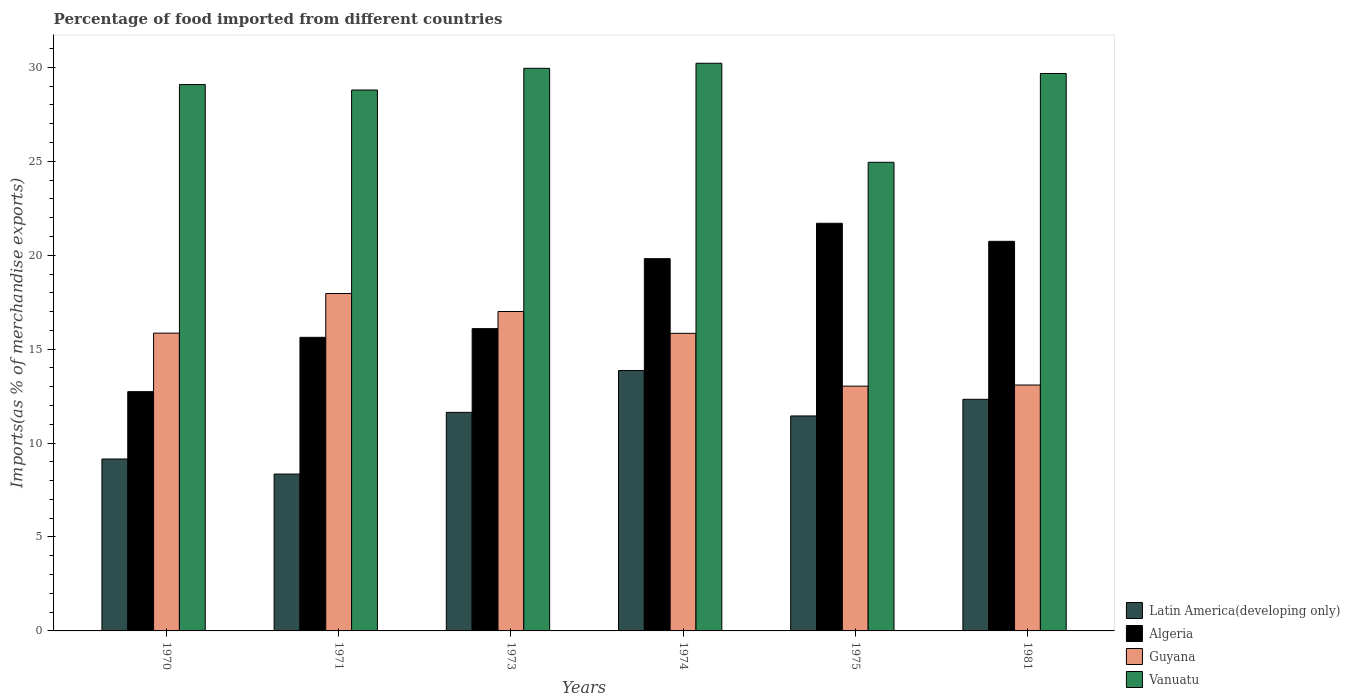Are the number of bars on each tick of the X-axis equal?
Ensure brevity in your answer.  Yes. How many bars are there on the 3rd tick from the right?
Your answer should be very brief. 4. What is the percentage of imports to different countries in Guyana in 1970?
Ensure brevity in your answer.  15.85. Across all years, what is the maximum percentage of imports to different countries in Algeria?
Ensure brevity in your answer.  21.7. Across all years, what is the minimum percentage of imports to different countries in Latin America(developing only)?
Make the answer very short. 8.35. What is the total percentage of imports to different countries in Algeria in the graph?
Your response must be concise. 106.72. What is the difference between the percentage of imports to different countries in Algeria in 1971 and that in 1974?
Offer a very short reply. -4.19. What is the difference between the percentage of imports to different countries in Latin America(developing only) in 1981 and the percentage of imports to different countries in Vanuatu in 1970?
Your response must be concise. -16.76. What is the average percentage of imports to different countries in Vanuatu per year?
Ensure brevity in your answer.  28.78. In the year 1973, what is the difference between the percentage of imports to different countries in Algeria and percentage of imports to different countries in Vanuatu?
Your answer should be very brief. -13.86. In how many years, is the percentage of imports to different countries in Vanuatu greater than 14 %?
Give a very brief answer. 6. What is the ratio of the percentage of imports to different countries in Latin America(developing only) in 1973 to that in 1981?
Offer a very short reply. 0.94. Is the percentage of imports to different countries in Algeria in 1973 less than that in 1975?
Give a very brief answer. Yes. What is the difference between the highest and the second highest percentage of imports to different countries in Latin America(developing only)?
Ensure brevity in your answer.  1.53. What is the difference between the highest and the lowest percentage of imports to different countries in Vanuatu?
Offer a very short reply. 5.27. In how many years, is the percentage of imports to different countries in Latin America(developing only) greater than the average percentage of imports to different countries in Latin America(developing only) taken over all years?
Your answer should be compact. 4. Is the sum of the percentage of imports to different countries in Guyana in 1973 and 1974 greater than the maximum percentage of imports to different countries in Vanuatu across all years?
Make the answer very short. Yes. Is it the case that in every year, the sum of the percentage of imports to different countries in Latin America(developing only) and percentage of imports to different countries in Algeria is greater than the sum of percentage of imports to different countries in Vanuatu and percentage of imports to different countries in Guyana?
Keep it short and to the point. No. What does the 3rd bar from the left in 1981 represents?
Your answer should be compact. Guyana. What does the 2nd bar from the right in 1971 represents?
Offer a terse response. Guyana. Is it the case that in every year, the sum of the percentage of imports to different countries in Vanuatu and percentage of imports to different countries in Algeria is greater than the percentage of imports to different countries in Latin America(developing only)?
Provide a succinct answer. Yes. Are all the bars in the graph horizontal?
Provide a succinct answer. No. How many years are there in the graph?
Ensure brevity in your answer.  6. Are the values on the major ticks of Y-axis written in scientific E-notation?
Offer a terse response. No. Does the graph contain any zero values?
Make the answer very short. No. Where does the legend appear in the graph?
Your answer should be compact. Bottom right. How many legend labels are there?
Keep it short and to the point. 4. What is the title of the graph?
Your answer should be very brief. Percentage of food imported from different countries. Does "Low & middle income" appear as one of the legend labels in the graph?
Offer a very short reply. No. What is the label or title of the Y-axis?
Provide a short and direct response. Imports(as % of merchandise exports). What is the Imports(as % of merchandise exports) of Latin America(developing only) in 1970?
Give a very brief answer. 9.15. What is the Imports(as % of merchandise exports) in Algeria in 1970?
Keep it short and to the point. 12.74. What is the Imports(as % of merchandise exports) of Guyana in 1970?
Provide a succinct answer. 15.85. What is the Imports(as % of merchandise exports) of Vanuatu in 1970?
Provide a succinct answer. 29.09. What is the Imports(as % of merchandise exports) in Latin America(developing only) in 1971?
Provide a succinct answer. 8.35. What is the Imports(as % of merchandise exports) in Algeria in 1971?
Ensure brevity in your answer.  15.63. What is the Imports(as % of merchandise exports) of Guyana in 1971?
Keep it short and to the point. 17.96. What is the Imports(as % of merchandise exports) in Vanuatu in 1971?
Make the answer very short. 28.8. What is the Imports(as % of merchandise exports) of Latin America(developing only) in 1973?
Offer a terse response. 11.64. What is the Imports(as % of merchandise exports) of Algeria in 1973?
Offer a very short reply. 16.09. What is the Imports(as % of merchandise exports) in Guyana in 1973?
Provide a succinct answer. 17. What is the Imports(as % of merchandise exports) of Vanuatu in 1973?
Your response must be concise. 29.95. What is the Imports(as % of merchandise exports) in Latin America(developing only) in 1974?
Ensure brevity in your answer.  13.86. What is the Imports(as % of merchandise exports) of Algeria in 1974?
Your answer should be compact. 19.82. What is the Imports(as % of merchandise exports) in Guyana in 1974?
Provide a succinct answer. 15.84. What is the Imports(as % of merchandise exports) in Vanuatu in 1974?
Keep it short and to the point. 30.22. What is the Imports(as % of merchandise exports) of Latin America(developing only) in 1975?
Give a very brief answer. 11.44. What is the Imports(as % of merchandise exports) in Algeria in 1975?
Offer a very short reply. 21.7. What is the Imports(as % of merchandise exports) of Guyana in 1975?
Provide a succinct answer. 13.03. What is the Imports(as % of merchandise exports) in Vanuatu in 1975?
Your response must be concise. 24.95. What is the Imports(as % of merchandise exports) in Latin America(developing only) in 1981?
Keep it short and to the point. 12.33. What is the Imports(as % of merchandise exports) in Algeria in 1981?
Your answer should be very brief. 20.74. What is the Imports(as % of merchandise exports) of Guyana in 1981?
Keep it short and to the point. 13.09. What is the Imports(as % of merchandise exports) of Vanuatu in 1981?
Offer a terse response. 29.67. Across all years, what is the maximum Imports(as % of merchandise exports) of Latin America(developing only)?
Offer a terse response. 13.86. Across all years, what is the maximum Imports(as % of merchandise exports) of Algeria?
Give a very brief answer. 21.7. Across all years, what is the maximum Imports(as % of merchandise exports) of Guyana?
Offer a very short reply. 17.96. Across all years, what is the maximum Imports(as % of merchandise exports) of Vanuatu?
Your response must be concise. 30.22. Across all years, what is the minimum Imports(as % of merchandise exports) in Latin America(developing only)?
Provide a succinct answer. 8.35. Across all years, what is the minimum Imports(as % of merchandise exports) of Algeria?
Provide a succinct answer. 12.74. Across all years, what is the minimum Imports(as % of merchandise exports) in Guyana?
Offer a terse response. 13.03. Across all years, what is the minimum Imports(as % of merchandise exports) in Vanuatu?
Provide a short and direct response. 24.95. What is the total Imports(as % of merchandise exports) of Latin America(developing only) in the graph?
Offer a very short reply. 66.77. What is the total Imports(as % of merchandise exports) of Algeria in the graph?
Make the answer very short. 106.72. What is the total Imports(as % of merchandise exports) of Guyana in the graph?
Your response must be concise. 92.78. What is the total Imports(as % of merchandise exports) in Vanuatu in the graph?
Provide a short and direct response. 172.68. What is the difference between the Imports(as % of merchandise exports) of Latin America(developing only) in 1970 and that in 1971?
Give a very brief answer. 0.8. What is the difference between the Imports(as % of merchandise exports) in Algeria in 1970 and that in 1971?
Provide a succinct answer. -2.89. What is the difference between the Imports(as % of merchandise exports) of Guyana in 1970 and that in 1971?
Give a very brief answer. -2.11. What is the difference between the Imports(as % of merchandise exports) in Vanuatu in 1970 and that in 1971?
Provide a short and direct response. 0.29. What is the difference between the Imports(as % of merchandise exports) in Latin America(developing only) in 1970 and that in 1973?
Your answer should be very brief. -2.48. What is the difference between the Imports(as % of merchandise exports) of Algeria in 1970 and that in 1973?
Offer a terse response. -3.36. What is the difference between the Imports(as % of merchandise exports) of Guyana in 1970 and that in 1973?
Provide a succinct answer. -1.15. What is the difference between the Imports(as % of merchandise exports) in Vanuatu in 1970 and that in 1973?
Offer a terse response. -0.86. What is the difference between the Imports(as % of merchandise exports) in Latin America(developing only) in 1970 and that in 1974?
Offer a very short reply. -4.71. What is the difference between the Imports(as % of merchandise exports) of Algeria in 1970 and that in 1974?
Your answer should be very brief. -7.08. What is the difference between the Imports(as % of merchandise exports) in Guyana in 1970 and that in 1974?
Make the answer very short. 0.01. What is the difference between the Imports(as % of merchandise exports) of Vanuatu in 1970 and that in 1974?
Provide a short and direct response. -1.13. What is the difference between the Imports(as % of merchandise exports) of Latin America(developing only) in 1970 and that in 1975?
Your answer should be compact. -2.29. What is the difference between the Imports(as % of merchandise exports) in Algeria in 1970 and that in 1975?
Keep it short and to the point. -8.96. What is the difference between the Imports(as % of merchandise exports) of Guyana in 1970 and that in 1975?
Your response must be concise. 2.82. What is the difference between the Imports(as % of merchandise exports) of Vanuatu in 1970 and that in 1975?
Your response must be concise. 4.14. What is the difference between the Imports(as % of merchandise exports) of Latin America(developing only) in 1970 and that in 1981?
Provide a succinct answer. -3.18. What is the difference between the Imports(as % of merchandise exports) of Algeria in 1970 and that in 1981?
Ensure brevity in your answer.  -8. What is the difference between the Imports(as % of merchandise exports) in Guyana in 1970 and that in 1981?
Your answer should be very brief. 2.76. What is the difference between the Imports(as % of merchandise exports) in Vanuatu in 1970 and that in 1981?
Offer a very short reply. -0.59. What is the difference between the Imports(as % of merchandise exports) in Latin America(developing only) in 1971 and that in 1973?
Offer a terse response. -3.28. What is the difference between the Imports(as % of merchandise exports) in Algeria in 1971 and that in 1973?
Offer a very short reply. -0.46. What is the difference between the Imports(as % of merchandise exports) of Guyana in 1971 and that in 1973?
Give a very brief answer. 0.96. What is the difference between the Imports(as % of merchandise exports) of Vanuatu in 1971 and that in 1973?
Give a very brief answer. -1.15. What is the difference between the Imports(as % of merchandise exports) of Latin America(developing only) in 1971 and that in 1974?
Offer a terse response. -5.51. What is the difference between the Imports(as % of merchandise exports) of Algeria in 1971 and that in 1974?
Make the answer very short. -4.19. What is the difference between the Imports(as % of merchandise exports) of Guyana in 1971 and that in 1974?
Offer a very short reply. 2.12. What is the difference between the Imports(as % of merchandise exports) of Vanuatu in 1971 and that in 1974?
Offer a very short reply. -1.42. What is the difference between the Imports(as % of merchandise exports) of Latin America(developing only) in 1971 and that in 1975?
Ensure brevity in your answer.  -3.09. What is the difference between the Imports(as % of merchandise exports) of Algeria in 1971 and that in 1975?
Provide a succinct answer. -6.07. What is the difference between the Imports(as % of merchandise exports) of Guyana in 1971 and that in 1975?
Your response must be concise. 4.93. What is the difference between the Imports(as % of merchandise exports) of Vanuatu in 1971 and that in 1975?
Your answer should be compact. 3.85. What is the difference between the Imports(as % of merchandise exports) in Latin America(developing only) in 1971 and that in 1981?
Keep it short and to the point. -3.98. What is the difference between the Imports(as % of merchandise exports) of Algeria in 1971 and that in 1981?
Offer a terse response. -5.11. What is the difference between the Imports(as % of merchandise exports) of Guyana in 1971 and that in 1981?
Make the answer very short. 4.87. What is the difference between the Imports(as % of merchandise exports) of Vanuatu in 1971 and that in 1981?
Your answer should be compact. -0.88. What is the difference between the Imports(as % of merchandise exports) in Latin America(developing only) in 1973 and that in 1974?
Provide a short and direct response. -2.23. What is the difference between the Imports(as % of merchandise exports) in Algeria in 1973 and that in 1974?
Offer a terse response. -3.72. What is the difference between the Imports(as % of merchandise exports) of Guyana in 1973 and that in 1974?
Provide a succinct answer. 1.16. What is the difference between the Imports(as % of merchandise exports) in Vanuatu in 1973 and that in 1974?
Give a very brief answer. -0.27. What is the difference between the Imports(as % of merchandise exports) in Latin America(developing only) in 1973 and that in 1975?
Your answer should be compact. 0.19. What is the difference between the Imports(as % of merchandise exports) of Algeria in 1973 and that in 1975?
Your answer should be very brief. -5.61. What is the difference between the Imports(as % of merchandise exports) of Guyana in 1973 and that in 1975?
Your response must be concise. 3.97. What is the difference between the Imports(as % of merchandise exports) in Vanuatu in 1973 and that in 1975?
Your answer should be very brief. 5. What is the difference between the Imports(as % of merchandise exports) of Latin America(developing only) in 1973 and that in 1981?
Provide a short and direct response. -0.7. What is the difference between the Imports(as % of merchandise exports) in Algeria in 1973 and that in 1981?
Ensure brevity in your answer.  -4.65. What is the difference between the Imports(as % of merchandise exports) in Guyana in 1973 and that in 1981?
Offer a very short reply. 3.91. What is the difference between the Imports(as % of merchandise exports) in Vanuatu in 1973 and that in 1981?
Make the answer very short. 0.28. What is the difference between the Imports(as % of merchandise exports) of Latin America(developing only) in 1974 and that in 1975?
Your answer should be very brief. 2.42. What is the difference between the Imports(as % of merchandise exports) of Algeria in 1974 and that in 1975?
Ensure brevity in your answer.  -1.88. What is the difference between the Imports(as % of merchandise exports) of Guyana in 1974 and that in 1975?
Ensure brevity in your answer.  2.81. What is the difference between the Imports(as % of merchandise exports) in Vanuatu in 1974 and that in 1975?
Give a very brief answer. 5.27. What is the difference between the Imports(as % of merchandise exports) of Latin America(developing only) in 1974 and that in 1981?
Give a very brief answer. 1.53. What is the difference between the Imports(as % of merchandise exports) of Algeria in 1974 and that in 1981?
Keep it short and to the point. -0.92. What is the difference between the Imports(as % of merchandise exports) in Guyana in 1974 and that in 1981?
Your answer should be very brief. 2.75. What is the difference between the Imports(as % of merchandise exports) of Vanuatu in 1974 and that in 1981?
Your answer should be compact. 0.55. What is the difference between the Imports(as % of merchandise exports) of Latin America(developing only) in 1975 and that in 1981?
Offer a very short reply. -0.89. What is the difference between the Imports(as % of merchandise exports) in Algeria in 1975 and that in 1981?
Give a very brief answer. 0.96. What is the difference between the Imports(as % of merchandise exports) in Guyana in 1975 and that in 1981?
Provide a succinct answer. -0.06. What is the difference between the Imports(as % of merchandise exports) of Vanuatu in 1975 and that in 1981?
Keep it short and to the point. -4.73. What is the difference between the Imports(as % of merchandise exports) in Latin America(developing only) in 1970 and the Imports(as % of merchandise exports) in Algeria in 1971?
Offer a terse response. -6.48. What is the difference between the Imports(as % of merchandise exports) of Latin America(developing only) in 1970 and the Imports(as % of merchandise exports) of Guyana in 1971?
Offer a terse response. -8.81. What is the difference between the Imports(as % of merchandise exports) in Latin America(developing only) in 1970 and the Imports(as % of merchandise exports) in Vanuatu in 1971?
Offer a terse response. -19.64. What is the difference between the Imports(as % of merchandise exports) of Algeria in 1970 and the Imports(as % of merchandise exports) of Guyana in 1971?
Offer a very short reply. -5.22. What is the difference between the Imports(as % of merchandise exports) of Algeria in 1970 and the Imports(as % of merchandise exports) of Vanuatu in 1971?
Your response must be concise. -16.06. What is the difference between the Imports(as % of merchandise exports) of Guyana in 1970 and the Imports(as % of merchandise exports) of Vanuatu in 1971?
Provide a short and direct response. -12.94. What is the difference between the Imports(as % of merchandise exports) in Latin America(developing only) in 1970 and the Imports(as % of merchandise exports) in Algeria in 1973?
Your answer should be compact. -6.94. What is the difference between the Imports(as % of merchandise exports) in Latin America(developing only) in 1970 and the Imports(as % of merchandise exports) in Guyana in 1973?
Provide a succinct answer. -7.85. What is the difference between the Imports(as % of merchandise exports) in Latin America(developing only) in 1970 and the Imports(as % of merchandise exports) in Vanuatu in 1973?
Offer a terse response. -20.8. What is the difference between the Imports(as % of merchandise exports) of Algeria in 1970 and the Imports(as % of merchandise exports) of Guyana in 1973?
Offer a terse response. -4.27. What is the difference between the Imports(as % of merchandise exports) in Algeria in 1970 and the Imports(as % of merchandise exports) in Vanuatu in 1973?
Give a very brief answer. -17.21. What is the difference between the Imports(as % of merchandise exports) in Guyana in 1970 and the Imports(as % of merchandise exports) in Vanuatu in 1973?
Give a very brief answer. -14.1. What is the difference between the Imports(as % of merchandise exports) of Latin America(developing only) in 1970 and the Imports(as % of merchandise exports) of Algeria in 1974?
Provide a succinct answer. -10.66. What is the difference between the Imports(as % of merchandise exports) of Latin America(developing only) in 1970 and the Imports(as % of merchandise exports) of Guyana in 1974?
Offer a very short reply. -6.69. What is the difference between the Imports(as % of merchandise exports) in Latin America(developing only) in 1970 and the Imports(as % of merchandise exports) in Vanuatu in 1974?
Keep it short and to the point. -21.07. What is the difference between the Imports(as % of merchandise exports) of Algeria in 1970 and the Imports(as % of merchandise exports) of Guyana in 1974?
Your answer should be compact. -3.11. What is the difference between the Imports(as % of merchandise exports) of Algeria in 1970 and the Imports(as % of merchandise exports) of Vanuatu in 1974?
Make the answer very short. -17.48. What is the difference between the Imports(as % of merchandise exports) in Guyana in 1970 and the Imports(as % of merchandise exports) in Vanuatu in 1974?
Offer a terse response. -14.37. What is the difference between the Imports(as % of merchandise exports) of Latin America(developing only) in 1970 and the Imports(as % of merchandise exports) of Algeria in 1975?
Make the answer very short. -12.55. What is the difference between the Imports(as % of merchandise exports) in Latin America(developing only) in 1970 and the Imports(as % of merchandise exports) in Guyana in 1975?
Provide a short and direct response. -3.88. What is the difference between the Imports(as % of merchandise exports) in Latin America(developing only) in 1970 and the Imports(as % of merchandise exports) in Vanuatu in 1975?
Keep it short and to the point. -15.8. What is the difference between the Imports(as % of merchandise exports) in Algeria in 1970 and the Imports(as % of merchandise exports) in Guyana in 1975?
Make the answer very short. -0.29. What is the difference between the Imports(as % of merchandise exports) of Algeria in 1970 and the Imports(as % of merchandise exports) of Vanuatu in 1975?
Make the answer very short. -12.21. What is the difference between the Imports(as % of merchandise exports) in Guyana in 1970 and the Imports(as % of merchandise exports) in Vanuatu in 1975?
Provide a succinct answer. -9.09. What is the difference between the Imports(as % of merchandise exports) in Latin America(developing only) in 1970 and the Imports(as % of merchandise exports) in Algeria in 1981?
Provide a succinct answer. -11.59. What is the difference between the Imports(as % of merchandise exports) in Latin America(developing only) in 1970 and the Imports(as % of merchandise exports) in Guyana in 1981?
Provide a short and direct response. -3.94. What is the difference between the Imports(as % of merchandise exports) of Latin America(developing only) in 1970 and the Imports(as % of merchandise exports) of Vanuatu in 1981?
Provide a succinct answer. -20.52. What is the difference between the Imports(as % of merchandise exports) in Algeria in 1970 and the Imports(as % of merchandise exports) in Guyana in 1981?
Keep it short and to the point. -0.35. What is the difference between the Imports(as % of merchandise exports) in Algeria in 1970 and the Imports(as % of merchandise exports) in Vanuatu in 1981?
Keep it short and to the point. -16.94. What is the difference between the Imports(as % of merchandise exports) of Guyana in 1970 and the Imports(as % of merchandise exports) of Vanuatu in 1981?
Keep it short and to the point. -13.82. What is the difference between the Imports(as % of merchandise exports) of Latin America(developing only) in 1971 and the Imports(as % of merchandise exports) of Algeria in 1973?
Offer a very short reply. -7.74. What is the difference between the Imports(as % of merchandise exports) of Latin America(developing only) in 1971 and the Imports(as % of merchandise exports) of Guyana in 1973?
Make the answer very short. -8.65. What is the difference between the Imports(as % of merchandise exports) of Latin America(developing only) in 1971 and the Imports(as % of merchandise exports) of Vanuatu in 1973?
Make the answer very short. -21.6. What is the difference between the Imports(as % of merchandise exports) in Algeria in 1971 and the Imports(as % of merchandise exports) in Guyana in 1973?
Provide a succinct answer. -1.37. What is the difference between the Imports(as % of merchandise exports) in Algeria in 1971 and the Imports(as % of merchandise exports) in Vanuatu in 1973?
Offer a terse response. -14.32. What is the difference between the Imports(as % of merchandise exports) in Guyana in 1971 and the Imports(as % of merchandise exports) in Vanuatu in 1973?
Offer a very short reply. -11.99. What is the difference between the Imports(as % of merchandise exports) in Latin America(developing only) in 1971 and the Imports(as % of merchandise exports) in Algeria in 1974?
Offer a terse response. -11.47. What is the difference between the Imports(as % of merchandise exports) in Latin America(developing only) in 1971 and the Imports(as % of merchandise exports) in Guyana in 1974?
Your answer should be compact. -7.49. What is the difference between the Imports(as % of merchandise exports) in Latin America(developing only) in 1971 and the Imports(as % of merchandise exports) in Vanuatu in 1974?
Offer a very short reply. -21.87. What is the difference between the Imports(as % of merchandise exports) in Algeria in 1971 and the Imports(as % of merchandise exports) in Guyana in 1974?
Make the answer very short. -0.21. What is the difference between the Imports(as % of merchandise exports) of Algeria in 1971 and the Imports(as % of merchandise exports) of Vanuatu in 1974?
Your response must be concise. -14.59. What is the difference between the Imports(as % of merchandise exports) in Guyana in 1971 and the Imports(as % of merchandise exports) in Vanuatu in 1974?
Keep it short and to the point. -12.26. What is the difference between the Imports(as % of merchandise exports) of Latin America(developing only) in 1971 and the Imports(as % of merchandise exports) of Algeria in 1975?
Your answer should be compact. -13.35. What is the difference between the Imports(as % of merchandise exports) of Latin America(developing only) in 1971 and the Imports(as % of merchandise exports) of Guyana in 1975?
Offer a very short reply. -4.68. What is the difference between the Imports(as % of merchandise exports) in Latin America(developing only) in 1971 and the Imports(as % of merchandise exports) in Vanuatu in 1975?
Keep it short and to the point. -16.6. What is the difference between the Imports(as % of merchandise exports) in Algeria in 1971 and the Imports(as % of merchandise exports) in Guyana in 1975?
Your response must be concise. 2.6. What is the difference between the Imports(as % of merchandise exports) in Algeria in 1971 and the Imports(as % of merchandise exports) in Vanuatu in 1975?
Keep it short and to the point. -9.32. What is the difference between the Imports(as % of merchandise exports) in Guyana in 1971 and the Imports(as % of merchandise exports) in Vanuatu in 1975?
Your answer should be very brief. -6.99. What is the difference between the Imports(as % of merchandise exports) of Latin America(developing only) in 1971 and the Imports(as % of merchandise exports) of Algeria in 1981?
Provide a succinct answer. -12.39. What is the difference between the Imports(as % of merchandise exports) in Latin America(developing only) in 1971 and the Imports(as % of merchandise exports) in Guyana in 1981?
Keep it short and to the point. -4.74. What is the difference between the Imports(as % of merchandise exports) of Latin America(developing only) in 1971 and the Imports(as % of merchandise exports) of Vanuatu in 1981?
Offer a terse response. -21.32. What is the difference between the Imports(as % of merchandise exports) in Algeria in 1971 and the Imports(as % of merchandise exports) in Guyana in 1981?
Provide a succinct answer. 2.54. What is the difference between the Imports(as % of merchandise exports) in Algeria in 1971 and the Imports(as % of merchandise exports) in Vanuatu in 1981?
Make the answer very short. -14.04. What is the difference between the Imports(as % of merchandise exports) of Guyana in 1971 and the Imports(as % of merchandise exports) of Vanuatu in 1981?
Make the answer very short. -11.71. What is the difference between the Imports(as % of merchandise exports) of Latin America(developing only) in 1973 and the Imports(as % of merchandise exports) of Algeria in 1974?
Your answer should be compact. -8.18. What is the difference between the Imports(as % of merchandise exports) of Latin America(developing only) in 1973 and the Imports(as % of merchandise exports) of Guyana in 1974?
Your answer should be compact. -4.21. What is the difference between the Imports(as % of merchandise exports) of Latin America(developing only) in 1973 and the Imports(as % of merchandise exports) of Vanuatu in 1974?
Keep it short and to the point. -18.58. What is the difference between the Imports(as % of merchandise exports) of Algeria in 1973 and the Imports(as % of merchandise exports) of Guyana in 1974?
Provide a short and direct response. 0.25. What is the difference between the Imports(as % of merchandise exports) in Algeria in 1973 and the Imports(as % of merchandise exports) in Vanuatu in 1974?
Your response must be concise. -14.13. What is the difference between the Imports(as % of merchandise exports) in Guyana in 1973 and the Imports(as % of merchandise exports) in Vanuatu in 1974?
Make the answer very short. -13.22. What is the difference between the Imports(as % of merchandise exports) in Latin America(developing only) in 1973 and the Imports(as % of merchandise exports) in Algeria in 1975?
Keep it short and to the point. -10.07. What is the difference between the Imports(as % of merchandise exports) in Latin America(developing only) in 1973 and the Imports(as % of merchandise exports) in Guyana in 1975?
Make the answer very short. -1.4. What is the difference between the Imports(as % of merchandise exports) in Latin America(developing only) in 1973 and the Imports(as % of merchandise exports) in Vanuatu in 1975?
Offer a very short reply. -13.31. What is the difference between the Imports(as % of merchandise exports) in Algeria in 1973 and the Imports(as % of merchandise exports) in Guyana in 1975?
Your answer should be compact. 3.06. What is the difference between the Imports(as % of merchandise exports) in Algeria in 1973 and the Imports(as % of merchandise exports) in Vanuatu in 1975?
Make the answer very short. -8.85. What is the difference between the Imports(as % of merchandise exports) in Guyana in 1973 and the Imports(as % of merchandise exports) in Vanuatu in 1975?
Keep it short and to the point. -7.94. What is the difference between the Imports(as % of merchandise exports) in Latin America(developing only) in 1973 and the Imports(as % of merchandise exports) in Algeria in 1981?
Your response must be concise. -9.11. What is the difference between the Imports(as % of merchandise exports) of Latin America(developing only) in 1973 and the Imports(as % of merchandise exports) of Guyana in 1981?
Offer a very short reply. -1.46. What is the difference between the Imports(as % of merchandise exports) of Latin America(developing only) in 1973 and the Imports(as % of merchandise exports) of Vanuatu in 1981?
Your answer should be compact. -18.04. What is the difference between the Imports(as % of merchandise exports) of Algeria in 1973 and the Imports(as % of merchandise exports) of Guyana in 1981?
Give a very brief answer. 3. What is the difference between the Imports(as % of merchandise exports) of Algeria in 1973 and the Imports(as % of merchandise exports) of Vanuatu in 1981?
Your response must be concise. -13.58. What is the difference between the Imports(as % of merchandise exports) in Guyana in 1973 and the Imports(as % of merchandise exports) in Vanuatu in 1981?
Provide a succinct answer. -12.67. What is the difference between the Imports(as % of merchandise exports) of Latin America(developing only) in 1974 and the Imports(as % of merchandise exports) of Algeria in 1975?
Your response must be concise. -7.84. What is the difference between the Imports(as % of merchandise exports) of Latin America(developing only) in 1974 and the Imports(as % of merchandise exports) of Guyana in 1975?
Give a very brief answer. 0.83. What is the difference between the Imports(as % of merchandise exports) in Latin America(developing only) in 1974 and the Imports(as % of merchandise exports) in Vanuatu in 1975?
Your answer should be very brief. -11.09. What is the difference between the Imports(as % of merchandise exports) of Algeria in 1974 and the Imports(as % of merchandise exports) of Guyana in 1975?
Your answer should be compact. 6.79. What is the difference between the Imports(as % of merchandise exports) of Algeria in 1974 and the Imports(as % of merchandise exports) of Vanuatu in 1975?
Your answer should be very brief. -5.13. What is the difference between the Imports(as % of merchandise exports) of Guyana in 1974 and the Imports(as % of merchandise exports) of Vanuatu in 1975?
Ensure brevity in your answer.  -9.11. What is the difference between the Imports(as % of merchandise exports) of Latin America(developing only) in 1974 and the Imports(as % of merchandise exports) of Algeria in 1981?
Your answer should be compact. -6.88. What is the difference between the Imports(as % of merchandise exports) in Latin America(developing only) in 1974 and the Imports(as % of merchandise exports) in Guyana in 1981?
Ensure brevity in your answer.  0.77. What is the difference between the Imports(as % of merchandise exports) in Latin America(developing only) in 1974 and the Imports(as % of merchandise exports) in Vanuatu in 1981?
Provide a succinct answer. -15.81. What is the difference between the Imports(as % of merchandise exports) in Algeria in 1974 and the Imports(as % of merchandise exports) in Guyana in 1981?
Ensure brevity in your answer.  6.73. What is the difference between the Imports(as % of merchandise exports) in Algeria in 1974 and the Imports(as % of merchandise exports) in Vanuatu in 1981?
Your answer should be compact. -9.86. What is the difference between the Imports(as % of merchandise exports) of Guyana in 1974 and the Imports(as % of merchandise exports) of Vanuatu in 1981?
Provide a short and direct response. -13.83. What is the difference between the Imports(as % of merchandise exports) in Latin America(developing only) in 1975 and the Imports(as % of merchandise exports) in Algeria in 1981?
Offer a very short reply. -9.3. What is the difference between the Imports(as % of merchandise exports) of Latin America(developing only) in 1975 and the Imports(as % of merchandise exports) of Guyana in 1981?
Your answer should be compact. -1.65. What is the difference between the Imports(as % of merchandise exports) of Latin America(developing only) in 1975 and the Imports(as % of merchandise exports) of Vanuatu in 1981?
Ensure brevity in your answer.  -18.23. What is the difference between the Imports(as % of merchandise exports) in Algeria in 1975 and the Imports(as % of merchandise exports) in Guyana in 1981?
Your answer should be very brief. 8.61. What is the difference between the Imports(as % of merchandise exports) in Algeria in 1975 and the Imports(as % of merchandise exports) in Vanuatu in 1981?
Your answer should be compact. -7.97. What is the difference between the Imports(as % of merchandise exports) in Guyana in 1975 and the Imports(as % of merchandise exports) in Vanuatu in 1981?
Offer a very short reply. -16.64. What is the average Imports(as % of merchandise exports) of Latin America(developing only) per year?
Keep it short and to the point. 11.13. What is the average Imports(as % of merchandise exports) in Algeria per year?
Ensure brevity in your answer.  17.79. What is the average Imports(as % of merchandise exports) in Guyana per year?
Offer a very short reply. 15.46. What is the average Imports(as % of merchandise exports) of Vanuatu per year?
Offer a very short reply. 28.78. In the year 1970, what is the difference between the Imports(as % of merchandise exports) of Latin America(developing only) and Imports(as % of merchandise exports) of Algeria?
Your answer should be very brief. -3.59. In the year 1970, what is the difference between the Imports(as % of merchandise exports) of Latin America(developing only) and Imports(as % of merchandise exports) of Guyana?
Provide a succinct answer. -6.7. In the year 1970, what is the difference between the Imports(as % of merchandise exports) of Latin America(developing only) and Imports(as % of merchandise exports) of Vanuatu?
Ensure brevity in your answer.  -19.94. In the year 1970, what is the difference between the Imports(as % of merchandise exports) of Algeria and Imports(as % of merchandise exports) of Guyana?
Your answer should be very brief. -3.12. In the year 1970, what is the difference between the Imports(as % of merchandise exports) in Algeria and Imports(as % of merchandise exports) in Vanuatu?
Give a very brief answer. -16.35. In the year 1970, what is the difference between the Imports(as % of merchandise exports) of Guyana and Imports(as % of merchandise exports) of Vanuatu?
Provide a short and direct response. -13.23. In the year 1971, what is the difference between the Imports(as % of merchandise exports) in Latin America(developing only) and Imports(as % of merchandise exports) in Algeria?
Ensure brevity in your answer.  -7.28. In the year 1971, what is the difference between the Imports(as % of merchandise exports) in Latin America(developing only) and Imports(as % of merchandise exports) in Guyana?
Provide a succinct answer. -9.61. In the year 1971, what is the difference between the Imports(as % of merchandise exports) in Latin America(developing only) and Imports(as % of merchandise exports) in Vanuatu?
Provide a short and direct response. -20.45. In the year 1971, what is the difference between the Imports(as % of merchandise exports) of Algeria and Imports(as % of merchandise exports) of Guyana?
Ensure brevity in your answer.  -2.33. In the year 1971, what is the difference between the Imports(as % of merchandise exports) in Algeria and Imports(as % of merchandise exports) in Vanuatu?
Ensure brevity in your answer.  -13.17. In the year 1971, what is the difference between the Imports(as % of merchandise exports) of Guyana and Imports(as % of merchandise exports) of Vanuatu?
Provide a succinct answer. -10.83. In the year 1973, what is the difference between the Imports(as % of merchandise exports) of Latin America(developing only) and Imports(as % of merchandise exports) of Algeria?
Your answer should be compact. -4.46. In the year 1973, what is the difference between the Imports(as % of merchandise exports) of Latin America(developing only) and Imports(as % of merchandise exports) of Guyana?
Provide a succinct answer. -5.37. In the year 1973, what is the difference between the Imports(as % of merchandise exports) in Latin America(developing only) and Imports(as % of merchandise exports) in Vanuatu?
Offer a very short reply. -18.31. In the year 1973, what is the difference between the Imports(as % of merchandise exports) in Algeria and Imports(as % of merchandise exports) in Guyana?
Your answer should be very brief. -0.91. In the year 1973, what is the difference between the Imports(as % of merchandise exports) of Algeria and Imports(as % of merchandise exports) of Vanuatu?
Provide a short and direct response. -13.86. In the year 1973, what is the difference between the Imports(as % of merchandise exports) in Guyana and Imports(as % of merchandise exports) in Vanuatu?
Provide a succinct answer. -12.95. In the year 1974, what is the difference between the Imports(as % of merchandise exports) of Latin America(developing only) and Imports(as % of merchandise exports) of Algeria?
Your answer should be compact. -5.96. In the year 1974, what is the difference between the Imports(as % of merchandise exports) in Latin America(developing only) and Imports(as % of merchandise exports) in Guyana?
Provide a short and direct response. -1.98. In the year 1974, what is the difference between the Imports(as % of merchandise exports) in Latin America(developing only) and Imports(as % of merchandise exports) in Vanuatu?
Your answer should be very brief. -16.36. In the year 1974, what is the difference between the Imports(as % of merchandise exports) in Algeria and Imports(as % of merchandise exports) in Guyana?
Ensure brevity in your answer.  3.97. In the year 1974, what is the difference between the Imports(as % of merchandise exports) in Algeria and Imports(as % of merchandise exports) in Vanuatu?
Offer a very short reply. -10.4. In the year 1974, what is the difference between the Imports(as % of merchandise exports) of Guyana and Imports(as % of merchandise exports) of Vanuatu?
Offer a terse response. -14.38. In the year 1975, what is the difference between the Imports(as % of merchandise exports) in Latin America(developing only) and Imports(as % of merchandise exports) in Algeria?
Your answer should be very brief. -10.26. In the year 1975, what is the difference between the Imports(as % of merchandise exports) in Latin America(developing only) and Imports(as % of merchandise exports) in Guyana?
Make the answer very short. -1.59. In the year 1975, what is the difference between the Imports(as % of merchandise exports) of Latin America(developing only) and Imports(as % of merchandise exports) of Vanuatu?
Provide a short and direct response. -13.5. In the year 1975, what is the difference between the Imports(as % of merchandise exports) in Algeria and Imports(as % of merchandise exports) in Guyana?
Offer a terse response. 8.67. In the year 1975, what is the difference between the Imports(as % of merchandise exports) in Algeria and Imports(as % of merchandise exports) in Vanuatu?
Make the answer very short. -3.25. In the year 1975, what is the difference between the Imports(as % of merchandise exports) of Guyana and Imports(as % of merchandise exports) of Vanuatu?
Keep it short and to the point. -11.92. In the year 1981, what is the difference between the Imports(as % of merchandise exports) of Latin America(developing only) and Imports(as % of merchandise exports) of Algeria?
Your answer should be very brief. -8.41. In the year 1981, what is the difference between the Imports(as % of merchandise exports) in Latin America(developing only) and Imports(as % of merchandise exports) in Guyana?
Your answer should be very brief. -0.76. In the year 1981, what is the difference between the Imports(as % of merchandise exports) of Latin America(developing only) and Imports(as % of merchandise exports) of Vanuatu?
Your response must be concise. -17.34. In the year 1981, what is the difference between the Imports(as % of merchandise exports) of Algeria and Imports(as % of merchandise exports) of Guyana?
Offer a very short reply. 7.65. In the year 1981, what is the difference between the Imports(as % of merchandise exports) of Algeria and Imports(as % of merchandise exports) of Vanuatu?
Provide a short and direct response. -8.93. In the year 1981, what is the difference between the Imports(as % of merchandise exports) in Guyana and Imports(as % of merchandise exports) in Vanuatu?
Make the answer very short. -16.58. What is the ratio of the Imports(as % of merchandise exports) of Latin America(developing only) in 1970 to that in 1971?
Ensure brevity in your answer.  1.1. What is the ratio of the Imports(as % of merchandise exports) of Algeria in 1970 to that in 1971?
Provide a succinct answer. 0.81. What is the ratio of the Imports(as % of merchandise exports) of Guyana in 1970 to that in 1971?
Give a very brief answer. 0.88. What is the ratio of the Imports(as % of merchandise exports) of Vanuatu in 1970 to that in 1971?
Your answer should be compact. 1.01. What is the ratio of the Imports(as % of merchandise exports) in Latin America(developing only) in 1970 to that in 1973?
Provide a short and direct response. 0.79. What is the ratio of the Imports(as % of merchandise exports) in Algeria in 1970 to that in 1973?
Offer a very short reply. 0.79. What is the ratio of the Imports(as % of merchandise exports) in Guyana in 1970 to that in 1973?
Your answer should be compact. 0.93. What is the ratio of the Imports(as % of merchandise exports) of Vanuatu in 1970 to that in 1973?
Keep it short and to the point. 0.97. What is the ratio of the Imports(as % of merchandise exports) of Latin America(developing only) in 1970 to that in 1974?
Your response must be concise. 0.66. What is the ratio of the Imports(as % of merchandise exports) of Algeria in 1970 to that in 1974?
Your answer should be compact. 0.64. What is the ratio of the Imports(as % of merchandise exports) of Guyana in 1970 to that in 1974?
Your answer should be very brief. 1. What is the ratio of the Imports(as % of merchandise exports) in Vanuatu in 1970 to that in 1974?
Ensure brevity in your answer.  0.96. What is the ratio of the Imports(as % of merchandise exports) in Latin America(developing only) in 1970 to that in 1975?
Make the answer very short. 0.8. What is the ratio of the Imports(as % of merchandise exports) in Algeria in 1970 to that in 1975?
Give a very brief answer. 0.59. What is the ratio of the Imports(as % of merchandise exports) in Guyana in 1970 to that in 1975?
Offer a terse response. 1.22. What is the ratio of the Imports(as % of merchandise exports) in Vanuatu in 1970 to that in 1975?
Ensure brevity in your answer.  1.17. What is the ratio of the Imports(as % of merchandise exports) of Latin America(developing only) in 1970 to that in 1981?
Ensure brevity in your answer.  0.74. What is the ratio of the Imports(as % of merchandise exports) of Algeria in 1970 to that in 1981?
Give a very brief answer. 0.61. What is the ratio of the Imports(as % of merchandise exports) in Guyana in 1970 to that in 1981?
Keep it short and to the point. 1.21. What is the ratio of the Imports(as % of merchandise exports) in Vanuatu in 1970 to that in 1981?
Provide a short and direct response. 0.98. What is the ratio of the Imports(as % of merchandise exports) in Latin America(developing only) in 1971 to that in 1973?
Provide a short and direct response. 0.72. What is the ratio of the Imports(as % of merchandise exports) of Algeria in 1971 to that in 1973?
Provide a succinct answer. 0.97. What is the ratio of the Imports(as % of merchandise exports) in Guyana in 1971 to that in 1973?
Offer a very short reply. 1.06. What is the ratio of the Imports(as % of merchandise exports) of Vanuatu in 1971 to that in 1973?
Offer a very short reply. 0.96. What is the ratio of the Imports(as % of merchandise exports) in Latin America(developing only) in 1971 to that in 1974?
Provide a short and direct response. 0.6. What is the ratio of the Imports(as % of merchandise exports) of Algeria in 1971 to that in 1974?
Your response must be concise. 0.79. What is the ratio of the Imports(as % of merchandise exports) in Guyana in 1971 to that in 1974?
Provide a succinct answer. 1.13. What is the ratio of the Imports(as % of merchandise exports) of Vanuatu in 1971 to that in 1974?
Offer a very short reply. 0.95. What is the ratio of the Imports(as % of merchandise exports) of Latin America(developing only) in 1971 to that in 1975?
Keep it short and to the point. 0.73. What is the ratio of the Imports(as % of merchandise exports) in Algeria in 1971 to that in 1975?
Keep it short and to the point. 0.72. What is the ratio of the Imports(as % of merchandise exports) in Guyana in 1971 to that in 1975?
Give a very brief answer. 1.38. What is the ratio of the Imports(as % of merchandise exports) in Vanuatu in 1971 to that in 1975?
Your answer should be compact. 1.15. What is the ratio of the Imports(as % of merchandise exports) in Latin America(developing only) in 1971 to that in 1981?
Provide a succinct answer. 0.68. What is the ratio of the Imports(as % of merchandise exports) in Algeria in 1971 to that in 1981?
Your answer should be compact. 0.75. What is the ratio of the Imports(as % of merchandise exports) of Guyana in 1971 to that in 1981?
Provide a succinct answer. 1.37. What is the ratio of the Imports(as % of merchandise exports) in Vanuatu in 1971 to that in 1981?
Your response must be concise. 0.97. What is the ratio of the Imports(as % of merchandise exports) in Latin America(developing only) in 1973 to that in 1974?
Your response must be concise. 0.84. What is the ratio of the Imports(as % of merchandise exports) in Algeria in 1973 to that in 1974?
Make the answer very short. 0.81. What is the ratio of the Imports(as % of merchandise exports) of Guyana in 1973 to that in 1974?
Give a very brief answer. 1.07. What is the ratio of the Imports(as % of merchandise exports) in Latin America(developing only) in 1973 to that in 1975?
Your answer should be very brief. 1.02. What is the ratio of the Imports(as % of merchandise exports) in Algeria in 1973 to that in 1975?
Ensure brevity in your answer.  0.74. What is the ratio of the Imports(as % of merchandise exports) in Guyana in 1973 to that in 1975?
Provide a succinct answer. 1.3. What is the ratio of the Imports(as % of merchandise exports) in Vanuatu in 1973 to that in 1975?
Keep it short and to the point. 1.2. What is the ratio of the Imports(as % of merchandise exports) in Latin America(developing only) in 1973 to that in 1981?
Keep it short and to the point. 0.94. What is the ratio of the Imports(as % of merchandise exports) in Algeria in 1973 to that in 1981?
Provide a succinct answer. 0.78. What is the ratio of the Imports(as % of merchandise exports) of Guyana in 1973 to that in 1981?
Ensure brevity in your answer.  1.3. What is the ratio of the Imports(as % of merchandise exports) of Vanuatu in 1973 to that in 1981?
Provide a short and direct response. 1.01. What is the ratio of the Imports(as % of merchandise exports) of Latin America(developing only) in 1974 to that in 1975?
Your answer should be compact. 1.21. What is the ratio of the Imports(as % of merchandise exports) of Algeria in 1974 to that in 1975?
Offer a very short reply. 0.91. What is the ratio of the Imports(as % of merchandise exports) of Guyana in 1974 to that in 1975?
Provide a short and direct response. 1.22. What is the ratio of the Imports(as % of merchandise exports) in Vanuatu in 1974 to that in 1975?
Offer a terse response. 1.21. What is the ratio of the Imports(as % of merchandise exports) in Latin America(developing only) in 1974 to that in 1981?
Make the answer very short. 1.12. What is the ratio of the Imports(as % of merchandise exports) in Algeria in 1974 to that in 1981?
Ensure brevity in your answer.  0.96. What is the ratio of the Imports(as % of merchandise exports) of Guyana in 1974 to that in 1981?
Offer a terse response. 1.21. What is the ratio of the Imports(as % of merchandise exports) in Vanuatu in 1974 to that in 1981?
Your answer should be compact. 1.02. What is the ratio of the Imports(as % of merchandise exports) in Latin America(developing only) in 1975 to that in 1981?
Offer a terse response. 0.93. What is the ratio of the Imports(as % of merchandise exports) of Algeria in 1975 to that in 1981?
Make the answer very short. 1.05. What is the ratio of the Imports(as % of merchandise exports) of Guyana in 1975 to that in 1981?
Make the answer very short. 1. What is the ratio of the Imports(as % of merchandise exports) of Vanuatu in 1975 to that in 1981?
Your response must be concise. 0.84. What is the difference between the highest and the second highest Imports(as % of merchandise exports) in Latin America(developing only)?
Your response must be concise. 1.53. What is the difference between the highest and the second highest Imports(as % of merchandise exports) in Algeria?
Offer a very short reply. 0.96. What is the difference between the highest and the second highest Imports(as % of merchandise exports) of Guyana?
Provide a short and direct response. 0.96. What is the difference between the highest and the second highest Imports(as % of merchandise exports) of Vanuatu?
Your answer should be very brief. 0.27. What is the difference between the highest and the lowest Imports(as % of merchandise exports) of Latin America(developing only)?
Offer a very short reply. 5.51. What is the difference between the highest and the lowest Imports(as % of merchandise exports) of Algeria?
Your answer should be compact. 8.96. What is the difference between the highest and the lowest Imports(as % of merchandise exports) of Guyana?
Provide a short and direct response. 4.93. What is the difference between the highest and the lowest Imports(as % of merchandise exports) in Vanuatu?
Give a very brief answer. 5.27. 